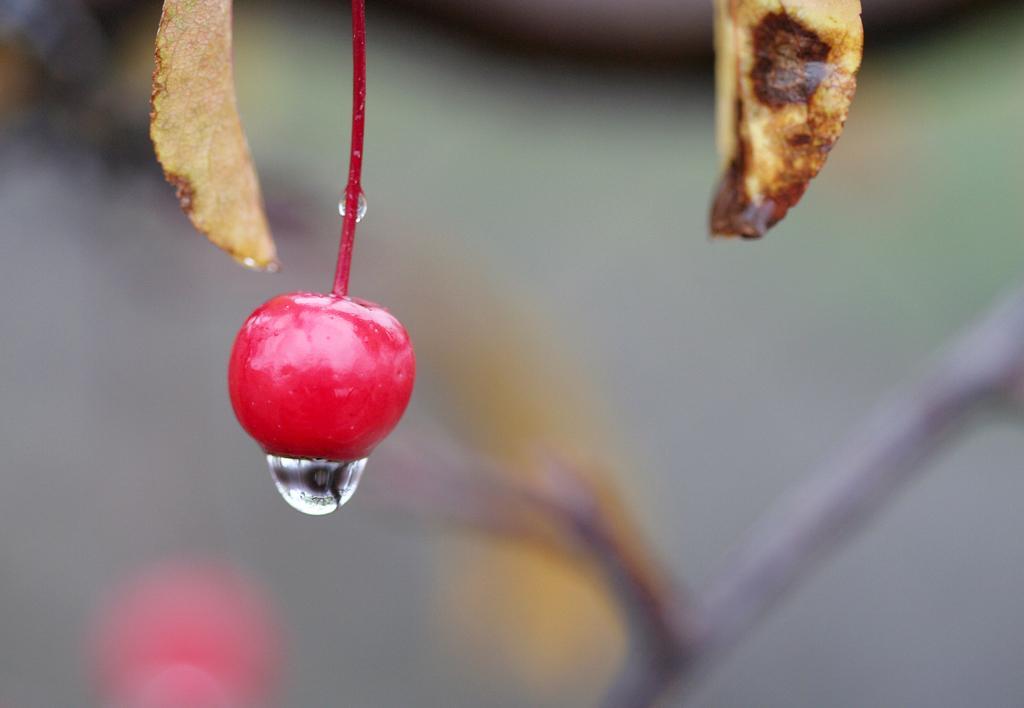Describe this image in one or two sentences. In the image it seems like there is a cherry and under the cherry there is a water droplet, the background of the cherry is blur. 